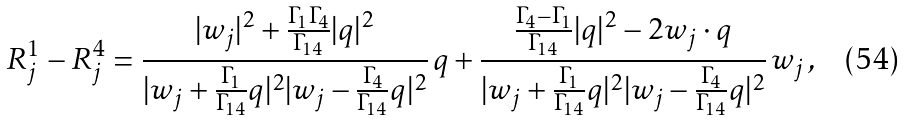Convert formula to latex. <formula><loc_0><loc_0><loc_500><loc_500>R _ { j } ^ { 1 } - R _ { j } ^ { 4 } = \frac { | w _ { j } | ^ { 2 } + \frac { \Gamma _ { 1 } \Gamma _ { 4 } } { \Gamma _ { 1 4 } } | q | ^ { 2 } } { | w _ { j } + \frac { \Gamma _ { 1 } } { \Gamma _ { 1 4 } } q | ^ { 2 } | w _ { j } - \frac { \Gamma _ { 4 } } { \Gamma _ { 1 4 } } q | ^ { 2 } } \, q + \frac { \frac { \Gamma _ { 4 } - \Gamma _ { 1 } } { \Gamma _ { 1 4 } } | q | ^ { 2 } - 2 w _ { j } \cdot q } { | w _ { j } + \frac { \Gamma _ { 1 } } { \Gamma _ { 1 4 } } q | ^ { 2 } | w _ { j } - \frac { \Gamma _ { 4 } } { \Gamma _ { 1 4 } } q | ^ { 2 } } \, w _ { j } \, ,</formula> 